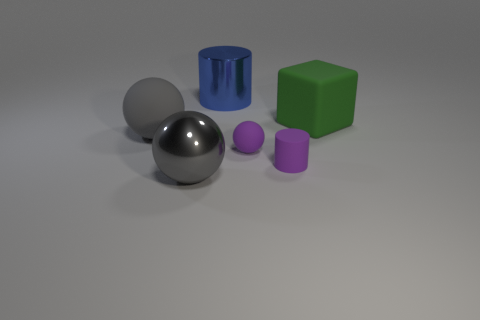There is a small purple ball that is on the right side of the gray metal ball; are there any metal balls in front of it?
Offer a very short reply. Yes. What is the material of the big thing that is on the left side of the big cylinder and behind the big gray metallic ball?
Ensure brevity in your answer.  Rubber. What shape is the purple thing that is made of the same material as the tiny purple cylinder?
Your answer should be compact. Sphere. Are there any other things that have the same shape as the green matte object?
Give a very brief answer. No. Are the sphere in front of the tiny matte cylinder and the blue cylinder made of the same material?
Give a very brief answer. Yes. What material is the cylinder that is on the right side of the big blue cylinder?
Ensure brevity in your answer.  Rubber. There is a shiny thing that is behind the big object to the right of the large blue cylinder; how big is it?
Give a very brief answer. Large. What number of blue cylinders have the same size as the gray matte object?
Give a very brief answer. 1. Does the rubber object in front of the tiny purple rubber sphere have the same color as the large matte block behind the purple cylinder?
Offer a very short reply. No. Are there any big blue objects in front of the purple rubber ball?
Provide a short and direct response. No. 